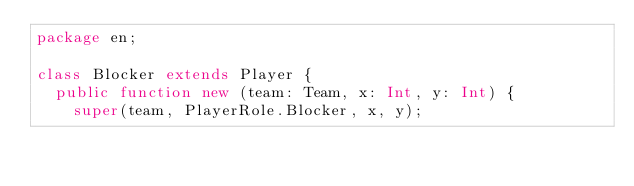Convert code to text. <code><loc_0><loc_0><loc_500><loc_500><_Haxe_>package en;

class Blocker extends Player {
	public function new (team: Team, x: Int, y: Int) {
		super(team, PlayerRole.Blocker, x, y);</code> 